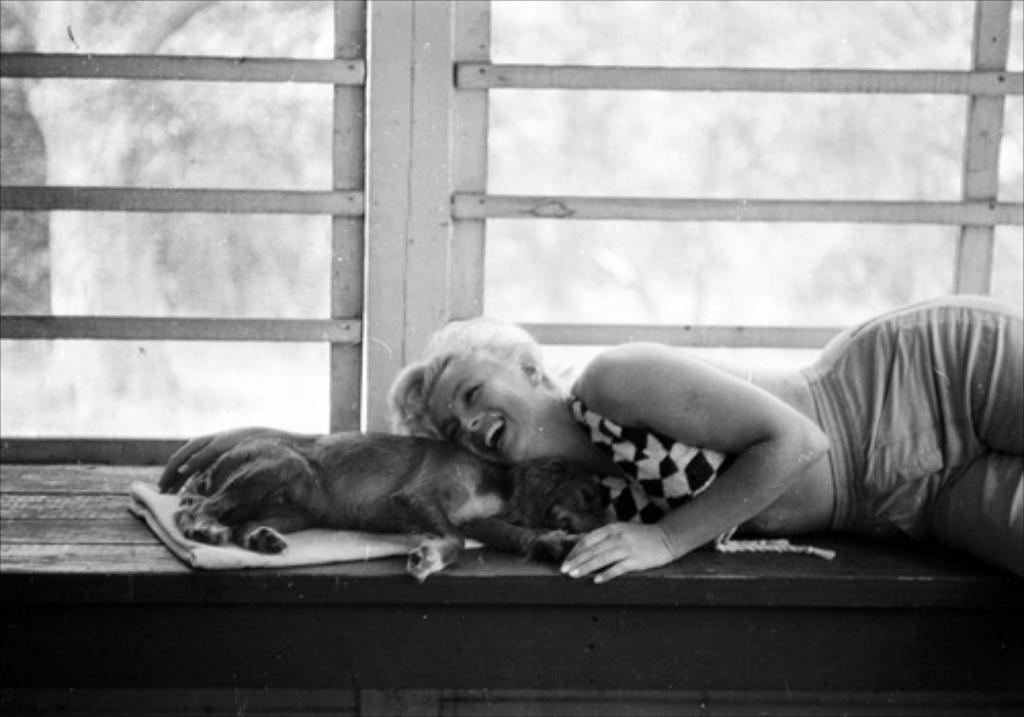Who is present in the image? There is a woman in the image. What is the woman doing in the image? The woman is lying down and smiling. Are there any animals in the image? Yes, there is a dog in the image. What type of linen is being used for the feast in the image? There is no feast or linen present in the image. What is the woman's occupation, and is she currently performing her duties in the image? The woman's occupation is not mentioned in the image, and there is no indication of her performing any duties. 